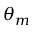Convert formula to latex. <formula><loc_0><loc_0><loc_500><loc_500>\theta _ { m }</formula> 